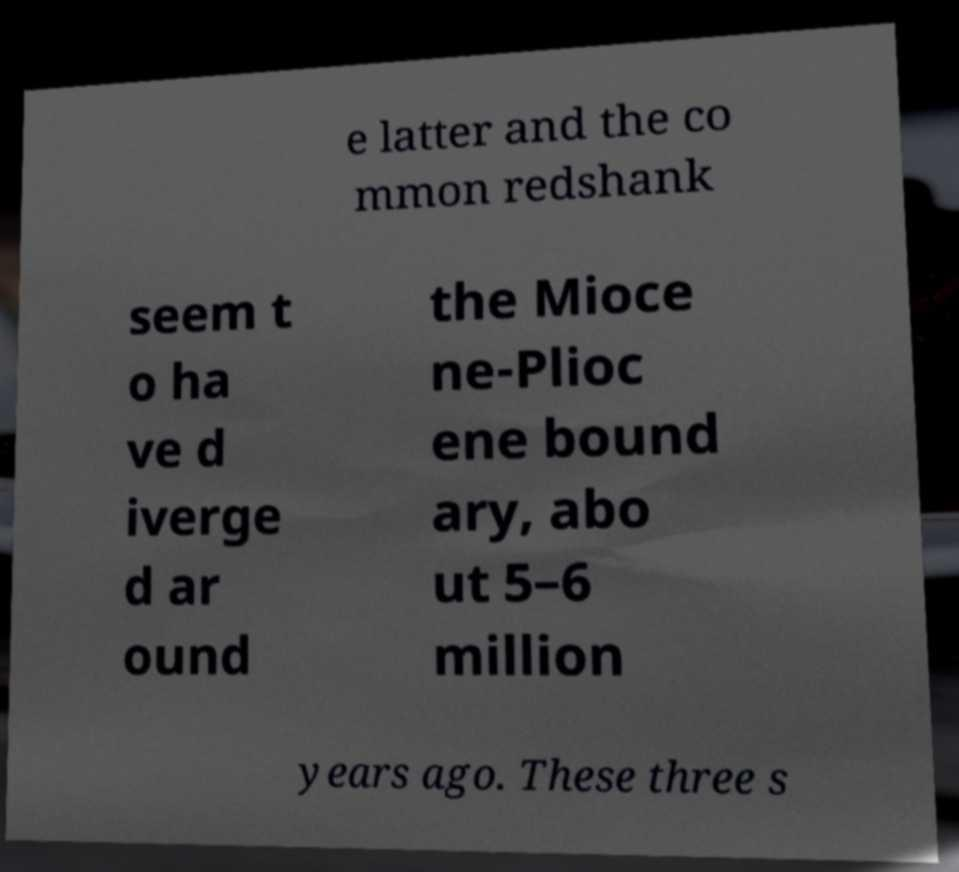I need the written content from this picture converted into text. Can you do that? e latter and the co mmon redshank seem t o ha ve d iverge d ar ound the Mioce ne-Plioc ene bound ary, abo ut 5–6 million years ago. These three s 